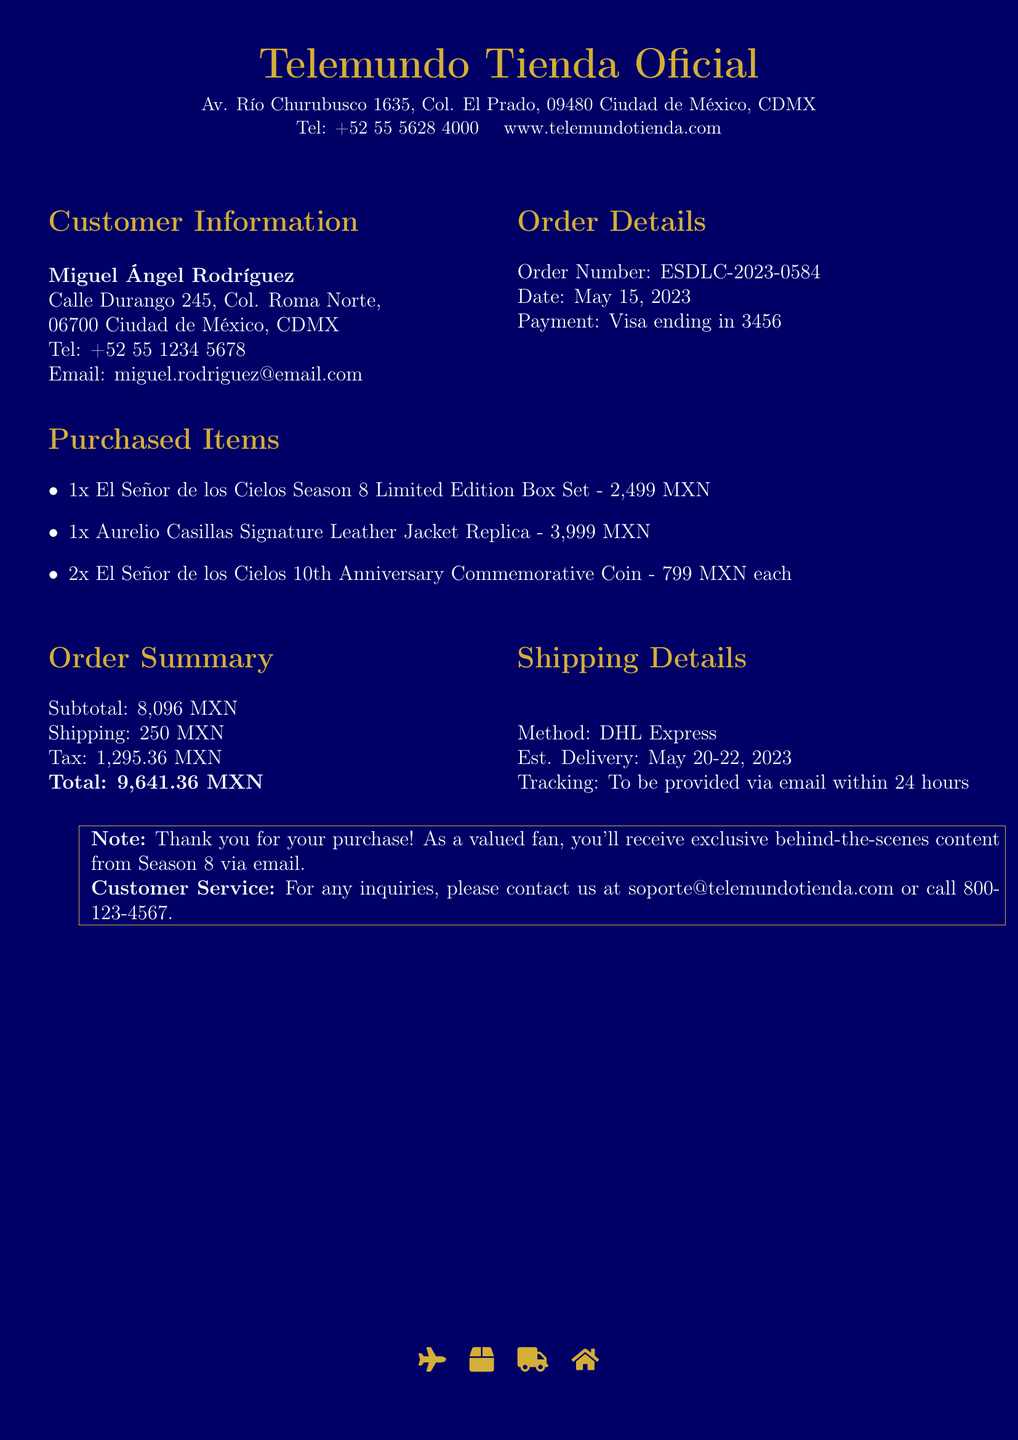What is the order number? The order number is a unique identifier for the purchase, which is listed in the document.
Answer: ESDLC-2023-0584 Who is the customer? The customer's name is provided at the beginning of the customer information section in the document.
Answer: Miguel Ángel Rodríguez What is the total amount due? The total amount due is provided in the order summary section at the end of the document.
Answer: 9,641.36 MXN What is the shipping method? The shipping method is specified in the shipping details section, indicating how the items will be delivered.
Answer: DHL Express How many commemorative coins were purchased? The number of commemorative coins can be found under the purchased items section where each item is listed.
Answer: 2 When is the estimated delivery date? The estimated delivery date is mentioned in the shipping details, indicating when the items are expected to arrive.
Answer: May 20-22, 2023 What type of payment was used? The payment type is recorded in the order details and signifies the method of payment for the order.
Answer: Visa ending in 3456 What is the subtotal before tax? The subtotal before the addition of shipping and tax is listed in the order summary section of the document.
Answer: 8,096 MXN What exclusive content will be received? The document includes a note indicating what additional content is received along with the purchase.
Answer: Behind-the-scenes content from Season 8 